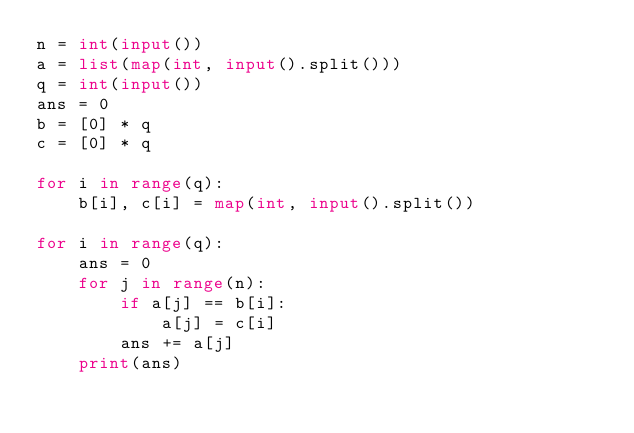<code> <loc_0><loc_0><loc_500><loc_500><_Python_>n = int(input())
a = list(map(int, input().split()))
q = int(input())
ans = 0
b = [0] * q
c = [0] * q

for i in range(q):
    b[i], c[i] = map(int, input().split())
    
for i in range(q):
    ans = 0
    for j in range(n):
        if a[j] == b[i]:
            a[j] = c[i]
        ans += a[j]
    print(ans)</code> 